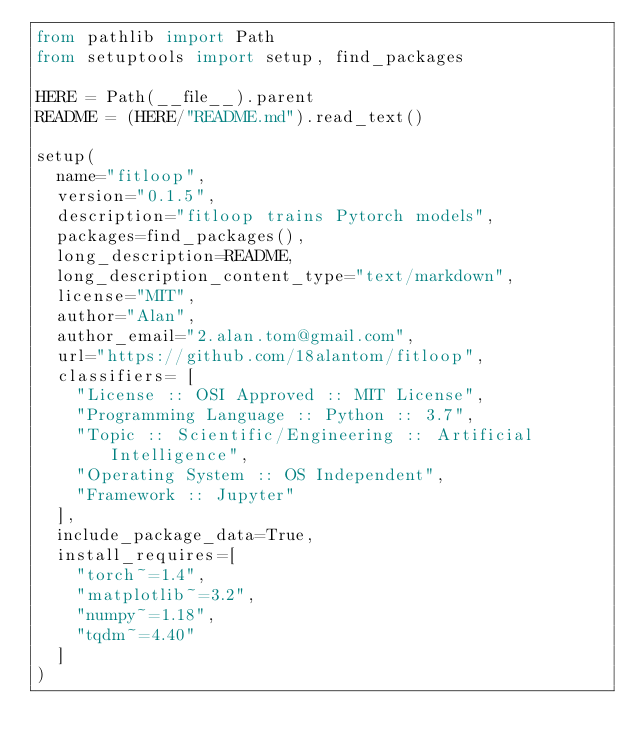Convert code to text. <code><loc_0><loc_0><loc_500><loc_500><_Python_>from pathlib import Path
from setuptools import setup, find_packages

HERE = Path(__file__).parent
README = (HERE/"README.md").read_text()

setup(
  name="fitloop",
  version="0.1.5",
  description="fitloop trains Pytorch models",
  packages=find_packages(),
  long_description=README,
  long_description_content_type="text/markdown",
  license="MIT",
  author="Alan",
  author_email="2.alan.tom@gmail.com",
  url="https://github.com/18alantom/fitloop",
  classifiers= [
    "License :: OSI Approved :: MIT License",
    "Programming Language :: Python :: 3.7",
    "Topic :: Scientific/Engineering :: Artificial Intelligence",
    "Operating System :: OS Independent",
    "Framework :: Jupyter"
  ],
  include_package_data=True,
  install_requires=[
    "torch~=1.4",
    "matplotlib~=3.2",
    "numpy~=1.18",
    "tqdm~=4.40"
  ]
)
</code> 